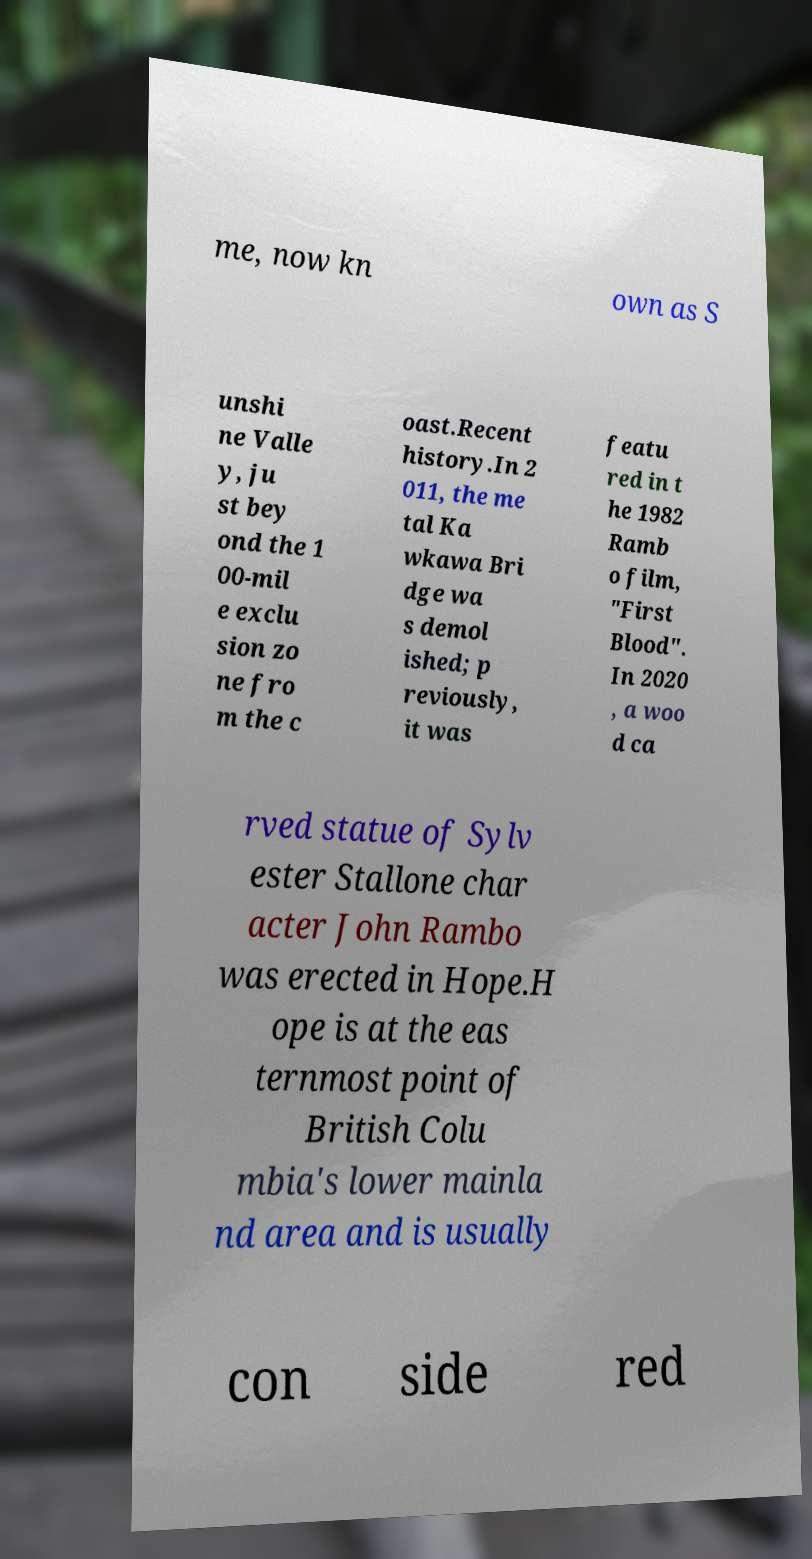Could you assist in decoding the text presented in this image and type it out clearly? me, now kn own as S unshi ne Valle y, ju st bey ond the 1 00-mil e exclu sion zo ne fro m the c oast.Recent history.In 2 011, the me tal Ka wkawa Bri dge wa s demol ished; p reviously, it was featu red in t he 1982 Ramb o film, "First Blood". In 2020 , a woo d ca rved statue of Sylv ester Stallone char acter John Rambo was erected in Hope.H ope is at the eas ternmost point of British Colu mbia's lower mainla nd area and is usually con side red 